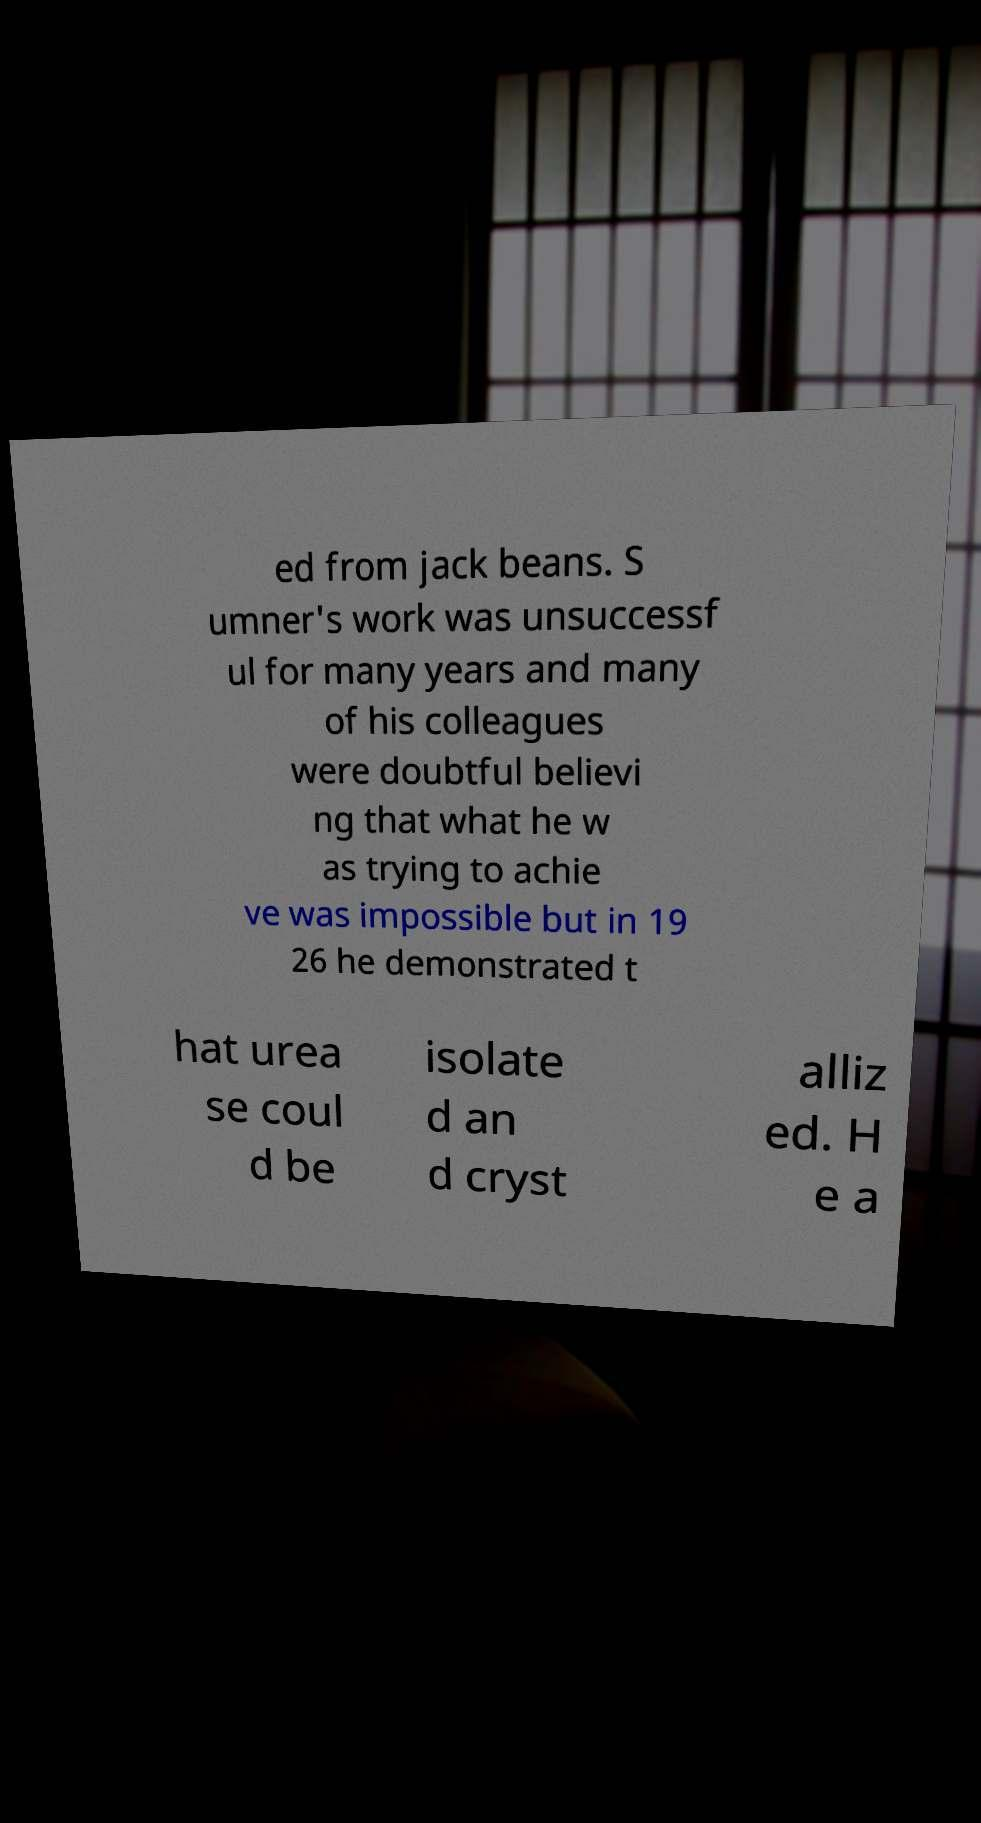Can you read and provide the text displayed in the image?This photo seems to have some interesting text. Can you extract and type it out for me? ed from jack beans. S umner's work was unsuccessf ul for many years and many of his colleagues were doubtful believi ng that what he w as trying to achie ve was impossible but in 19 26 he demonstrated t hat urea se coul d be isolate d an d cryst alliz ed. H e a 